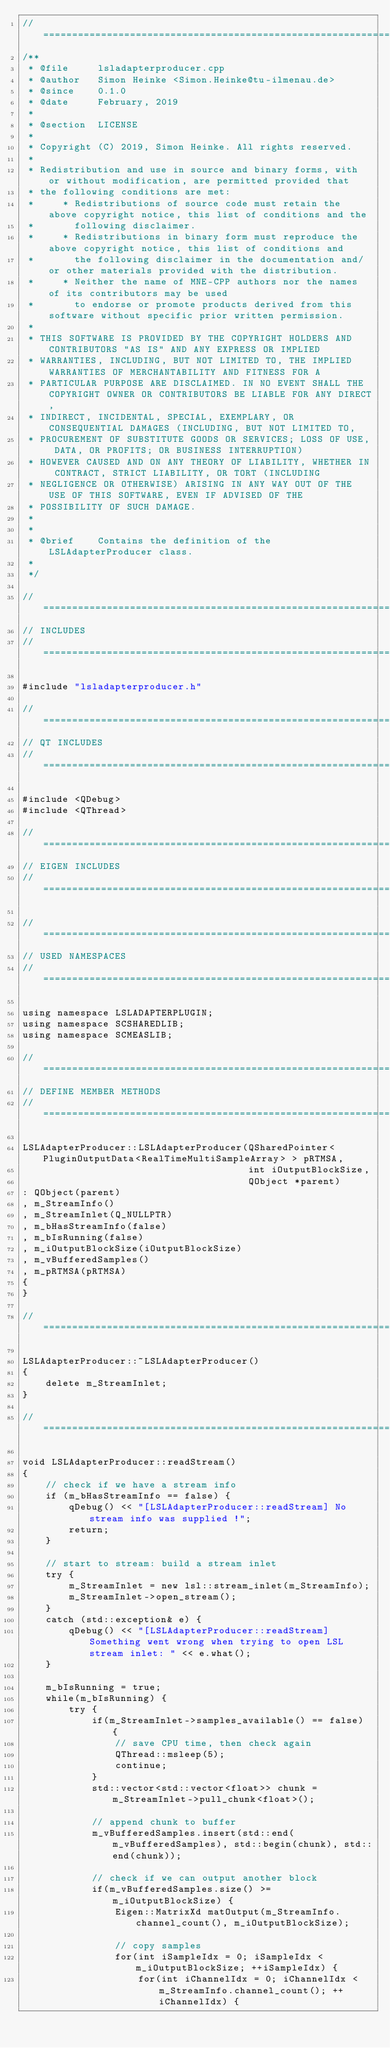<code> <loc_0><loc_0><loc_500><loc_500><_C++_>//=============================================================================================================
/**
 * @file     lsladapterproducer.cpp
 * @author   Simon Heinke <Simon.Heinke@tu-ilmenau.de>
 * @since    0.1.0
 * @date     February, 2019
 *
 * @section  LICENSE
 *
 * Copyright (C) 2019, Simon Heinke. All rights reserved.
 *
 * Redistribution and use in source and binary forms, with or without modification, are permitted provided that
 * the following conditions are met:
 *     * Redistributions of source code must retain the above copyright notice, this list of conditions and the
 *       following disclaimer.
 *     * Redistributions in binary form must reproduce the above copyright notice, this list of conditions and
 *       the following disclaimer in the documentation and/or other materials provided with the distribution.
 *     * Neither the name of MNE-CPP authors nor the names of its contributors may be used
 *       to endorse or promote products derived from this software without specific prior written permission.
 *
 * THIS SOFTWARE IS PROVIDED BY THE COPYRIGHT HOLDERS AND CONTRIBUTORS "AS IS" AND ANY EXPRESS OR IMPLIED
 * WARRANTIES, INCLUDING, BUT NOT LIMITED TO, THE IMPLIED WARRANTIES OF MERCHANTABILITY AND FITNESS FOR A
 * PARTICULAR PURPOSE ARE DISCLAIMED. IN NO EVENT SHALL THE COPYRIGHT OWNER OR CONTRIBUTORS BE LIABLE FOR ANY DIRECT,
 * INDIRECT, INCIDENTAL, SPECIAL, EXEMPLARY, OR CONSEQUENTIAL DAMAGES (INCLUDING, BUT NOT LIMITED TO,
 * PROCUREMENT OF SUBSTITUTE GOODS OR SERVICES; LOSS OF USE, DATA, OR PROFITS; OR BUSINESS INTERRUPTION)
 * HOWEVER CAUSED AND ON ANY THEORY OF LIABILITY, WHETHER IN CONTRACT, STRICT LIABILITY, OR TORT (INCLUDING
 * NEGLIGENCE OR OTHERWISE) ARISING IN ANY WAY OUT OF THE USE OF THIS SOFTWARE, EVEN IF ADVISED OF THE
 * POSSIBILITY OF SUCH DAMAGE.
 *
 *
 * @brief    Contains the definition of the LSLAdapterProducer class.
 *
 */

//=============================================================================================================
// INCLUDES
//=============================================================================================================

#include "lsladapterproducer.h"

//=============================================================================================================
// QT INCLUDES
//=============================================================================================================

#include <QDebug>
#include <QThread>

//=============================================================================================================
// EIGEN INCLUDES
//=============================================================================================================

//=============================================================================================================
// USED NAMESPACES
//=============================================================================================================

using namespace LSLADAPTERPLUGIN;
using namespace SCSHAREDLIB;
using namespace SCMEASLIB;

//=============================================================================================================
// DEFINE MEMBER METHODS
//=============================================================================================================

LSLAdapterProducer::LSLAdapterProducer(QSharedPointer<PluginOutputData<RealTimeMultiSampleArray> > pRTMSA,
                                       int iOutputBlockSize,
                                       QObject *parent)
: QObject(parent)
, m_StreamInfo()
, m_StreamInlet(Q_NULLPTR)
, m_bHasStreamInfo(false)
, m_bIsRunning(false)
, m_iOutputBlockSize(iOutputBlockSize)
, m_vBufferedSamples()
, m_pRTMSA(pRTMSA)
{
}

//=============================================================================================================

LSLAdapterProducer::~LSLAdapterProducer()
{
    delete m_StreamInlet;
}

//=============================================================================================================

void LSLAdapterProducer::readStream()
{   
    // check if we have a stream info
    if (m_bHasStreamInfo == false) {
        qDebug() << "[LSLAdapterProducer::readStream] No stream info was supplied !";
        return;
    }

    // start to stream: build a stream inlet
    try {
        m_StreamInlet = new lsl::stream_inlet(m_StreamInfo);
        m_StreamInlet->open_stream();
    }
    catch (std::exception& e) {
        qDebug() << "[LSLAdapterProducer::readStream] Something went wrong when trying to open LSL stream inlet: " << e.what();
    }

    m_bIsRunning = true;
    while(m_bIsRunning) {
        try {
            if(m_StreamInlet->samples_available() == false) {
                // save CPU time, then check again
                QThread::msleep(5);
                continue;
            }
            std::vector<std::vector<float>> chunk = m_StreamInlet->pull_chunk<float>();

            // append chunk to buffer
            m_vBufferedSamples.insert(std::end(m_vBufferedSamples), std::begin(chunk), std::end(chunk));

            // check if we can output another block
            if(m_vBufferedSamples.size() >= m_iOutputBlockSize) {
                Eigen::MatrixXd matOutput(m_StreamInfo.channel_count(), m_iOutputBlockSize);

                // copy samples
                for(int iSampleIdx = 0; iSampleIdx < m_iOutputBlockSize; ++iSampleIdx) {
                    for(int iChannelIdx = 0; iChannelIdx < m_StreamInfo.channel_count(); ++iChannelIdx) {</code> 